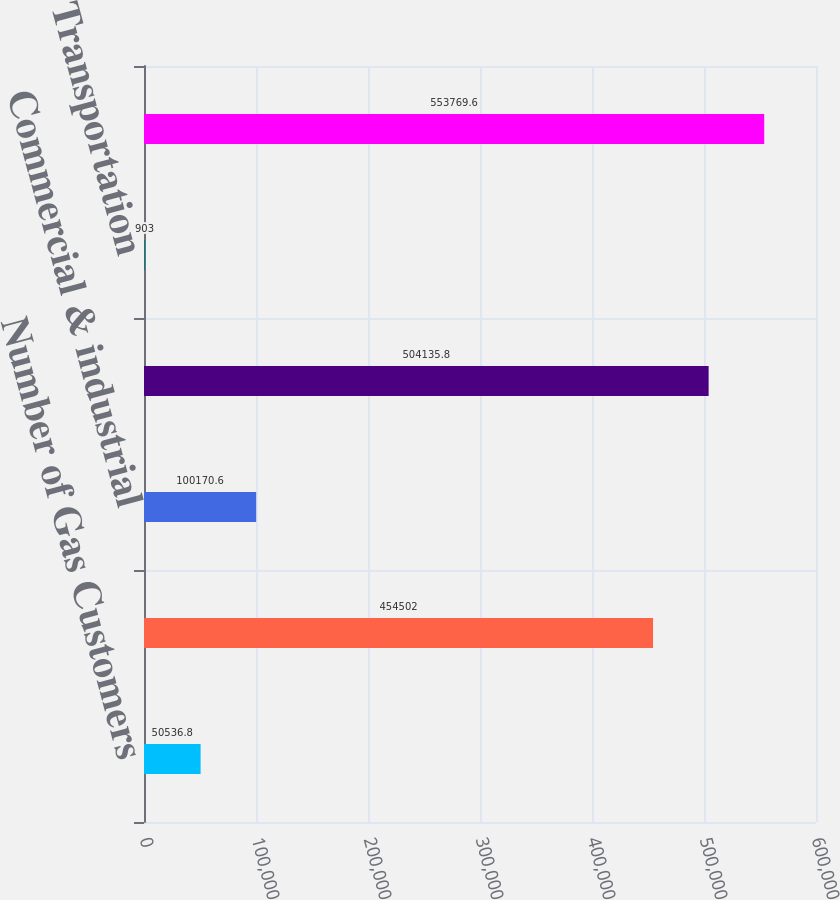Convert chart. <chart><loc_0><loc_0><loc_500><loc_500><bar_chart><fcel>Number of Gas Customers<fcel>Residential<fcel>Commercial & industrial<fcel>Total Retail<fcel>Transportation<fcel>Total<nl><fcel>50536.8<fcel>454502<fcel>100171<fcel>504136<fcel>903<fcel>553770<nl></chart> 